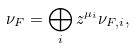<formula> <loc_0><loc_0><loc_500><loc_500>\nu _ { F } = \bigoplus _ { i } z ^ { \mu _ { i } } \nu _ { F , i } ,</formula> 